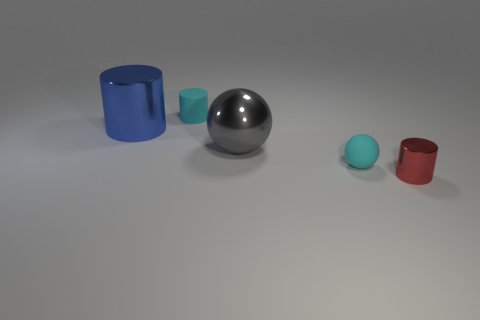Add 1 big metal things. How many objects exist? 6 Subtract all balls. How many objects are left? 3 Add 4 tiny gray objects. How many tiny gray objects exist? 4 Subtract 0 yellow cylinders. How many objects are left? 5 Subtract all big metal spheres. Subtract all shiny things. How many objects are left? 1 Add 2 tiny red shiny cylinders. How many tiny red shiny cylinders are left? 3 